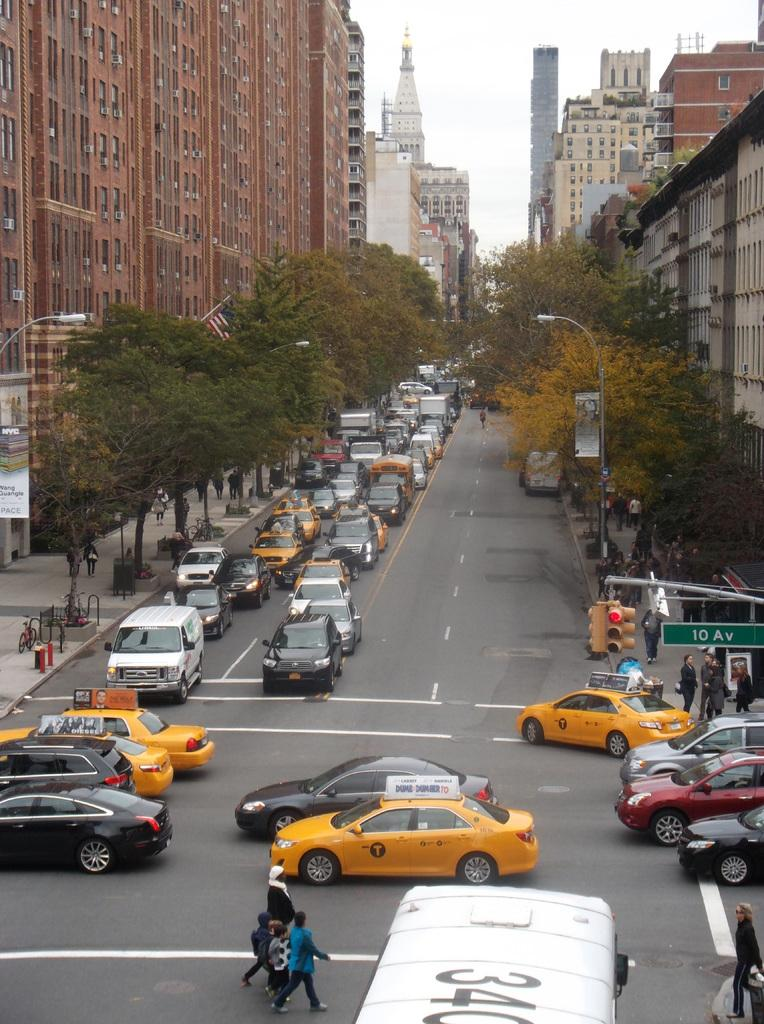<image>
Relay a brief, clear account of the picture shown. Cars passing by a busy street on 10 Av 